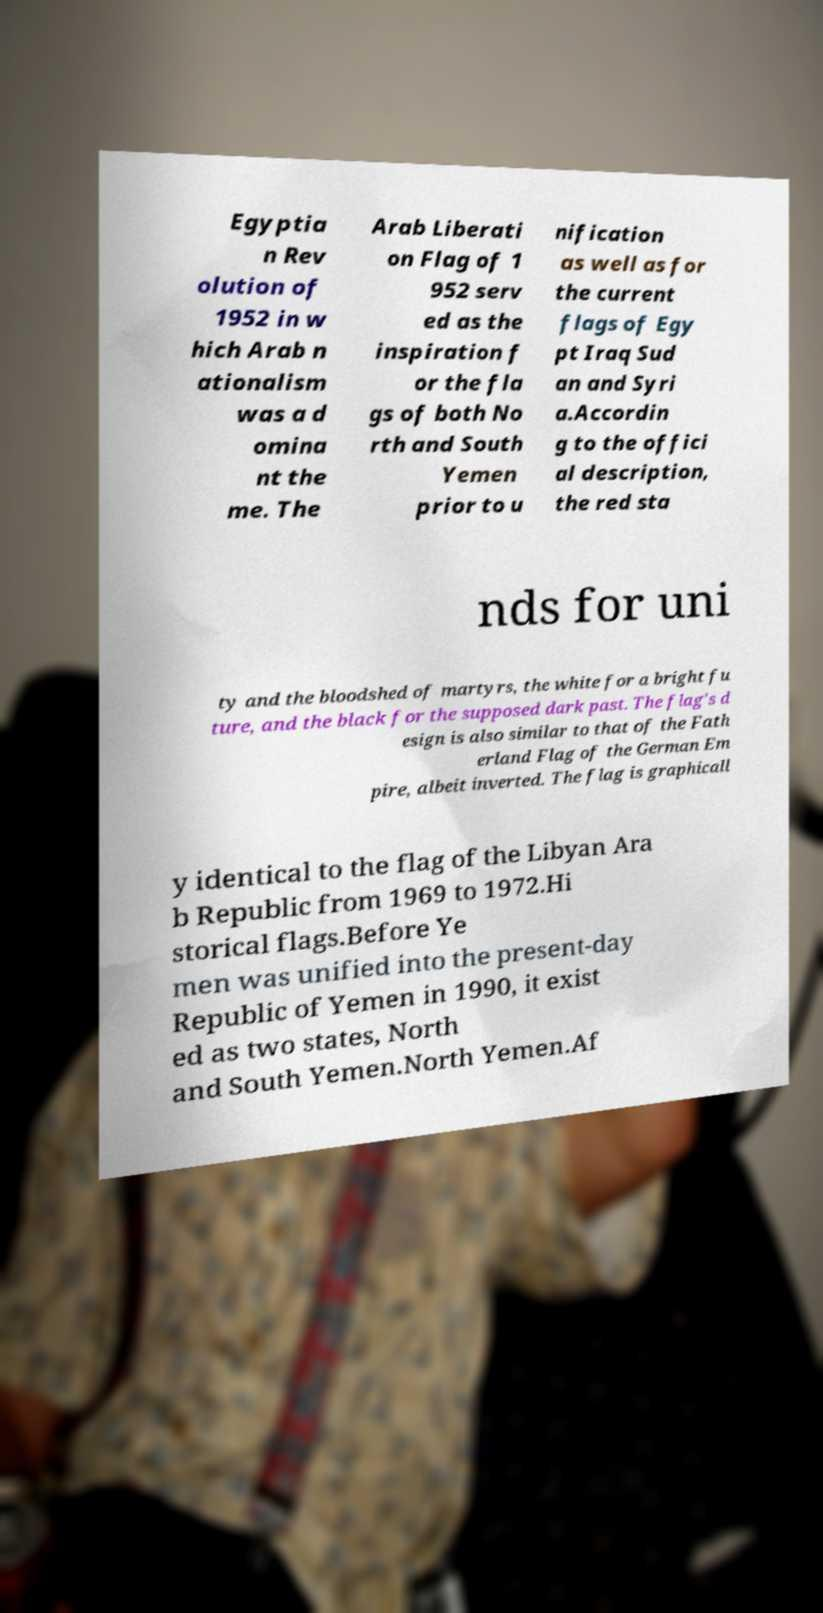Please identify and transcribe the text found in this image. Egyptia n Rev olution of 1952 in w hich Arab n ationalism was a d omina nt the me. The Arab Liberati on Flag of 1 952 serv ed as the inspiration f or the fla gs of both No rth and South Yemen prior to u nification as well as for the current flags of Egy pt Iraq Sud an and Syri a.Accordin g to the offici al description, the red sta nds for uni ty and the bloodshed of martyrs, the white for a bright fu ture, and the black for the supposed dark past. The flag's d esign is also similar to that of the Fath erland Flag of the German Em pire, albeit inverted. The flag is graphicall y identical to the flag of the Libyan Ara b Republic from 1969 to 1972.Hi storical flags.Before Ye men was unified into the present-day Republic of Yemen in 1990, it exist ed as two states, North and South Yemen.North Yemen.Af 